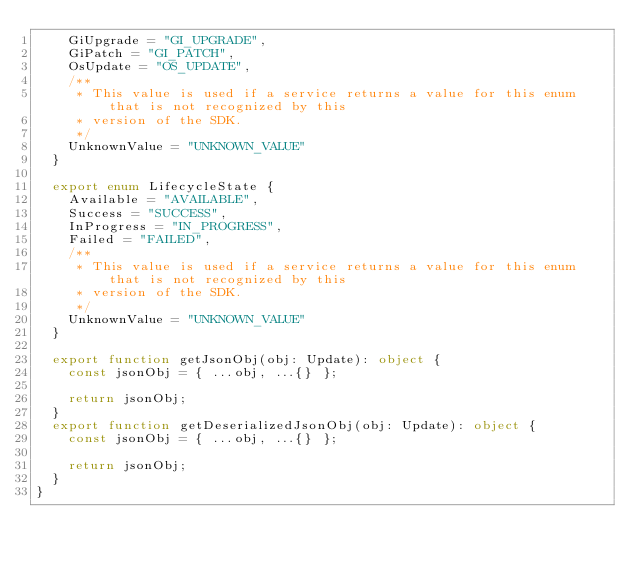<code> <loc_0><loc_0><loc_500><loc_500><_TypeScript_>    GiUpgrade = "GI_UPGRADE",
    GiPatch = "GI_PATCH",
    OsUpdate = "OS_UPDATE",
    /**
     * This value is used if a service returns a value for this enum that is not recognized by this
     * version of the SDK.
     */
    UnknownValue = "UNKNOWN_VALUE"
  }

  export enum LifecycleState {
    Available = "AVAILABLE",
    Success = "SUCCESS",
    InProgress = "IN_PROGRESS",
    Failed = "FAILED",
    /**
     * This value is used if a service returns a value for this enum that is not recognized by this
     * version of the SDK.
     */
    UnknownValue = "UNKNOWN_VALUE"
  }

  export function getJsonObj(obj: Update): object {
    const jsonObj = { ...obj, ...{} };

    return jsonObj;
  }
  export function getDeserializedJsonObj(obj: Update): object {
    const jsonObj = { ...obj, ...{} };

    return jsonObj;
  }
}
</code> 